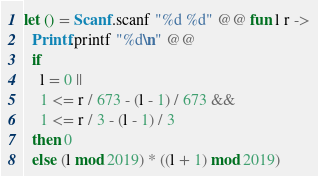<code> <loc_0><loc_0><loc_500><loc_500><_OCaml_>let () = Scanf.scanf "%d %d" @@ fun l r ->
  Printf.printf "%d\n" @@
  if
    l = 0 ||
    1 <= r / 673 - (l - 1) / 673 &&
    1 <= r / 3 - (l - 1) / 3
  then 0
  else (l mod 2019) * ((l + 1) mod 2019)

</code> 